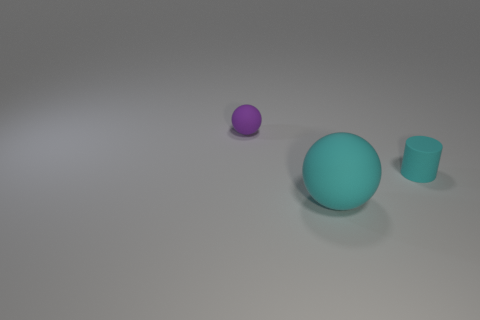Is there any other thing that is the same size as the cyan matte sphere?
Make the answer very short. No. There is a object that is on the right side of the matte ball that is right of the sphere left of the big cyan sphere; how big is it?
Provide a short and direct response. Small. Are there any purple matte things that have the same size as the purple matte sphere?
Provide a short and direct response. No. There is a cyan matte object on the right side of the cyan matte sphere; does it have the same size as the tiny purple sphere?
Keep it short and to the point. Yes. There is a rubber object that is right of the small matte sphere and left of the cyan cylinder; what shape is it?
Your response must be concise. Sphere. Is the number of small objects that are to the right of the purple ball greater than the number of small red rubber balls?
Offer a very short reply. Yes. What is the size of the cylinder that is the same material as the cyan ball?
Make the answer very short. Small. How many matte things have the same color as the large rubber sphere?
Provide a short and direct response. 1. Do the small matte object that is right of the large sphere and the large matte object have the same color?
Make the answer very short. Yes. Is the number of cyan spheres to the right of the big sphere the same as the number of tiny things that are left of the cyan cylinder?
Offer a terse response. No. 